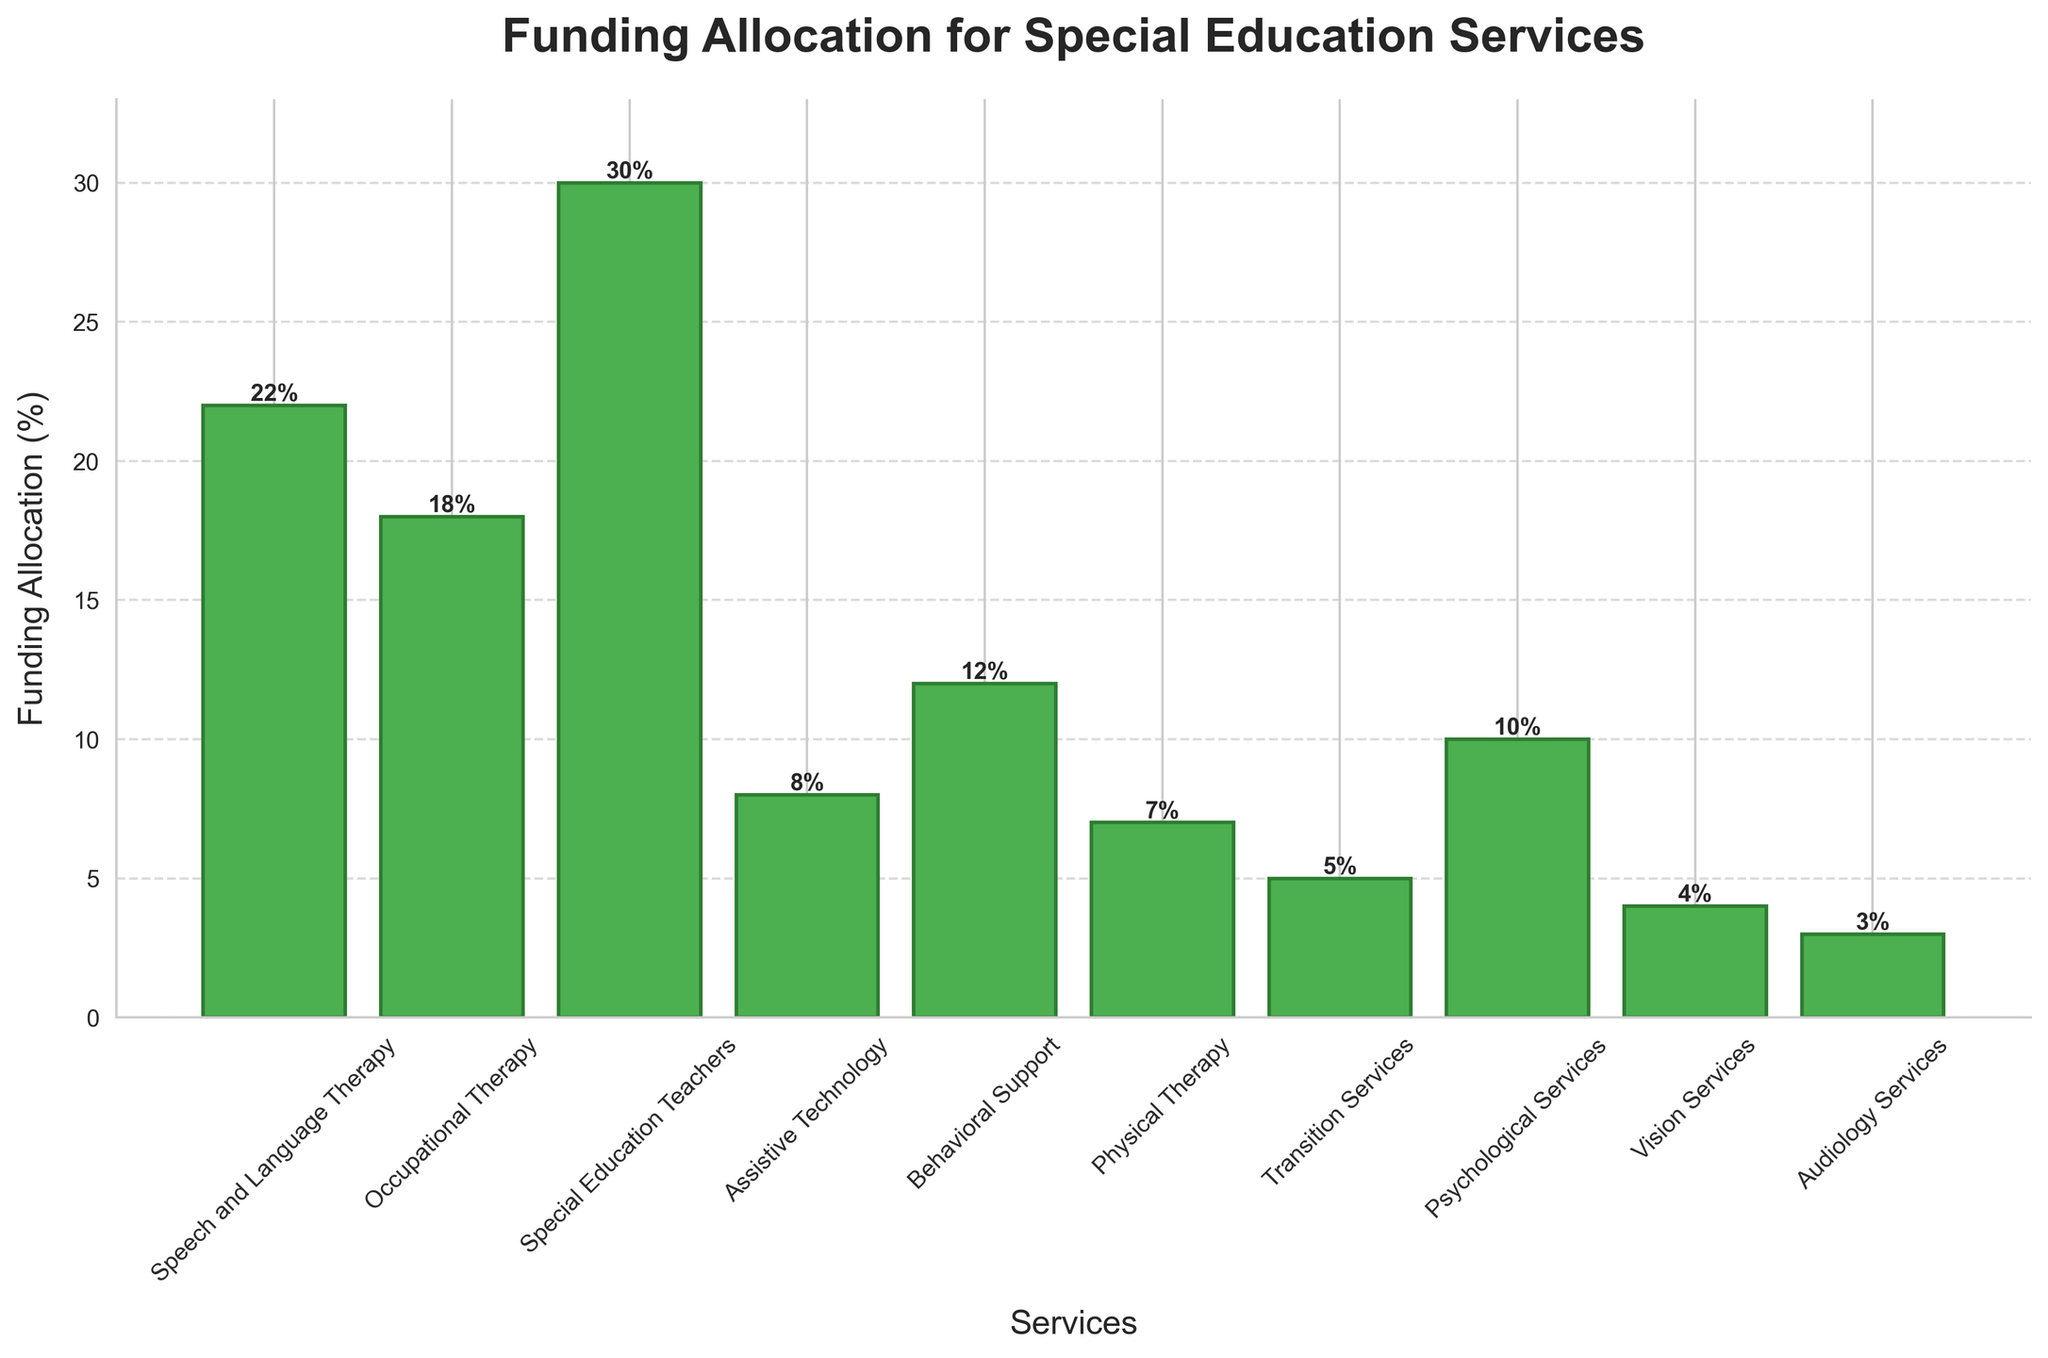What percentage of funding is allocated to Special Education Teachers? The percentage allocation is directly labeled for Special Education Teachers in the bar chart. Look at the bar corresponding to Special Education Teachers and read the value.
Answer: 30% Which service receives the least funding allocation, and what is the percentage? Compare the lengths of all the bars in the chart. The shortest bar represents the service with the least funding allocation. The label on this bar will give you the percentage.
Answer: Audiology Services, 3% What is the total funding allocation percentage for both Occupational Therapy and Behavioral Support? Identify the funding percentages for Occupational Therapy (18%) and Behavioral Support (12%). Add these two values together to get the total allocation percentage. 18 + 12 = 30
Answer: 30% Is the funding allocation for Psychological Services greater than or less than Vision Services? Compare the heights of the bars for Psychological Services (10%) and Vision Services (4%). The taller bar indicates a greater percentage.
Answer: Greater than What is the combined percentage of funding allocated to Assistive Technology, Transition Services, and Vision Services? Find the percentages allocated to Assistive Technology (8%), Transition Services (5%), and Vision Services (4%). Add these values together: 8 + 5 + 4 = 17
Answer: 17% Which service has a funding allocation percentage closest to 10%? Find the percentages that are close to 10% on the chart and determine which one is exactly, or nearest to, 10%. Psychological Services is labeled as 10%.
Answer: Psychological Services How much higher is the funding allocation for Speech and Language Therapy compared to Physical Therapy? Find the percentages for Speech and Language Therapy (22%) and Physical Therapy (7%). Subtract the smaller value from the larger one: 22 - 7 = 15
Answer: 15% Are there more services with a funding allocation above 10% or below 10%? Count the number of bars above 10% and those below 10%. There are 4 bars above 10% (30%, 22%, 18%, 12%) and 6 bars below 10% (10%, 8%, 7%, 5%, 4%, 3%).
Answer: Below 10% What is the average funding allocation percentage for all services? Add all the percentages for each service and then divide by the number of services. (22 + 18 + 30 + 8 + 12 + 7 + 5 + 10 + 4 + 3) / 10 = 11.9
Answer: 11.9% Which two services together have the highest total funding allocation percentage? Calculate the combined percentages for all pairs of services, and identify the pair with the highest total. Special Education Teachers (30%) and Speech and Language Therapy (22%) together have 52%.
Answer: Special Education Teachers and Speech and Language Therapy, 52% 